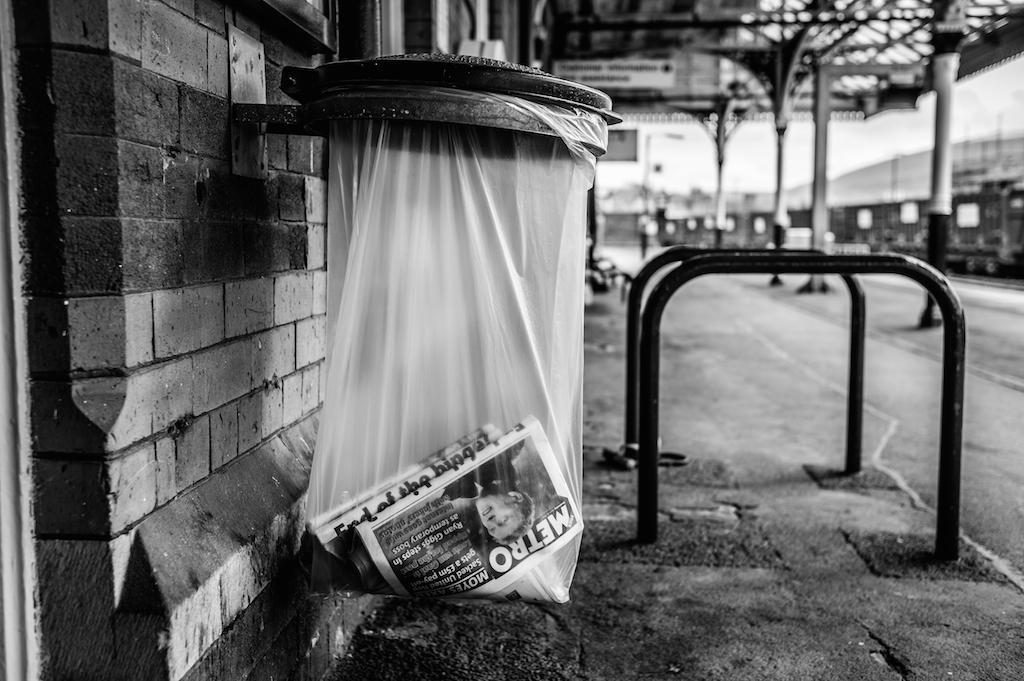What news paper is in the trash basket?
Your response must be concise. Metro. What is the title of the artical?
Your response must be concise. Metro. 